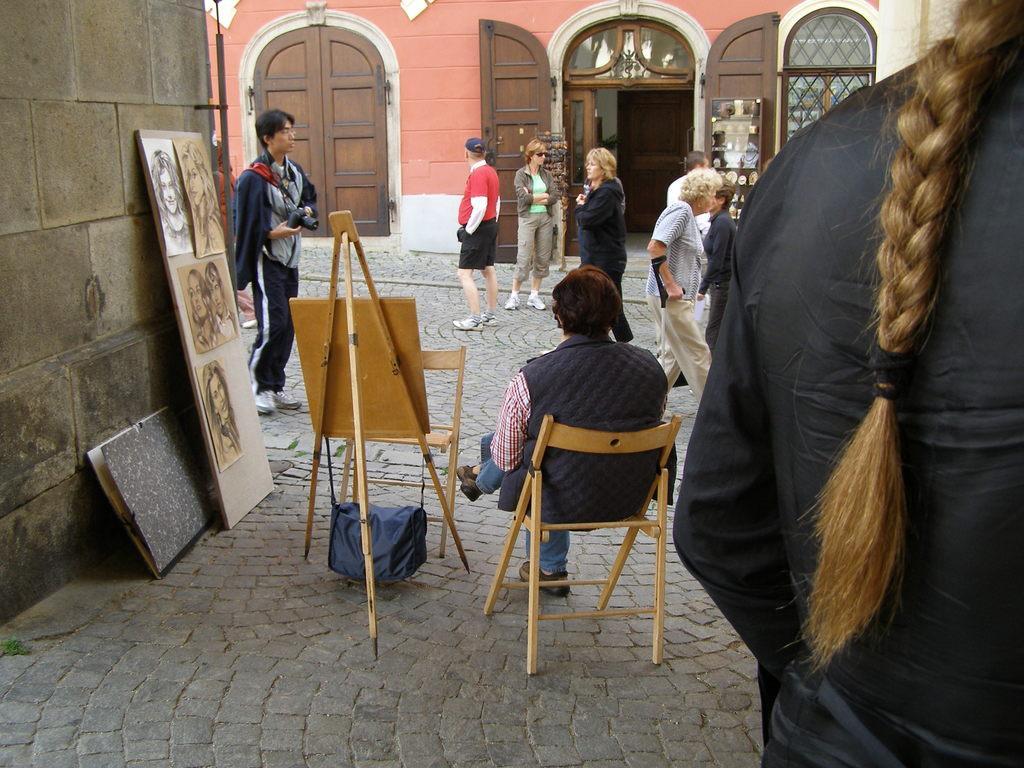Could you give a brief overview of what you see in this image? Girl standing,person is sitting on the chair,door,person walking,these are photos there is window. 